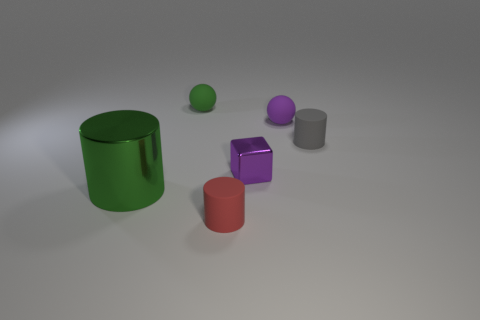Is there a sense of depth in this scene, and if so, how is it created? Depth is suggested in the scene by the size and placement of objects. Those that are larger and closer to the bottom edge of the frame appear closer to the viewer, while smaller objects set higher up and further back seem more distant, creating a sense of three-dimensional space. 